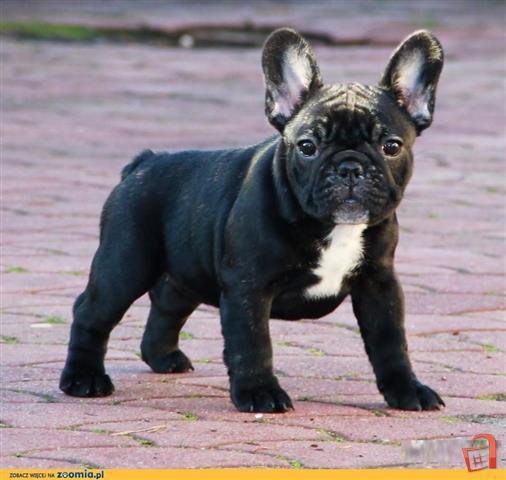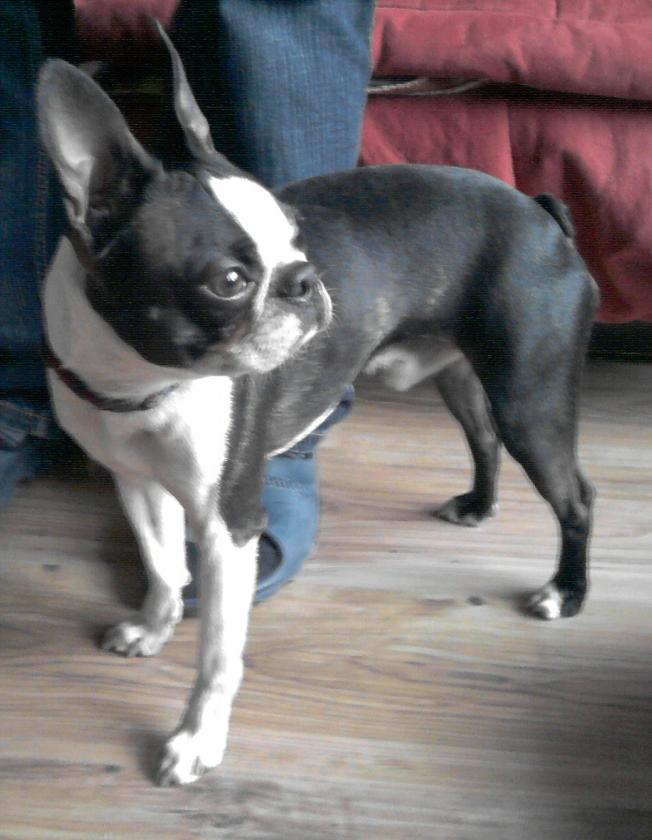The first image is the image on the left, the second image is the image on the right. Examine the images to the left and right. Is the description "There are at most two dogs." accurate? Answer yes or no. Yes. The first image is the image on the left, the second image is the image on the right. Assess this claim about the two images: "Both dogs are standing on all four feet.". Correct or not? Answer yes or no. Yes. 